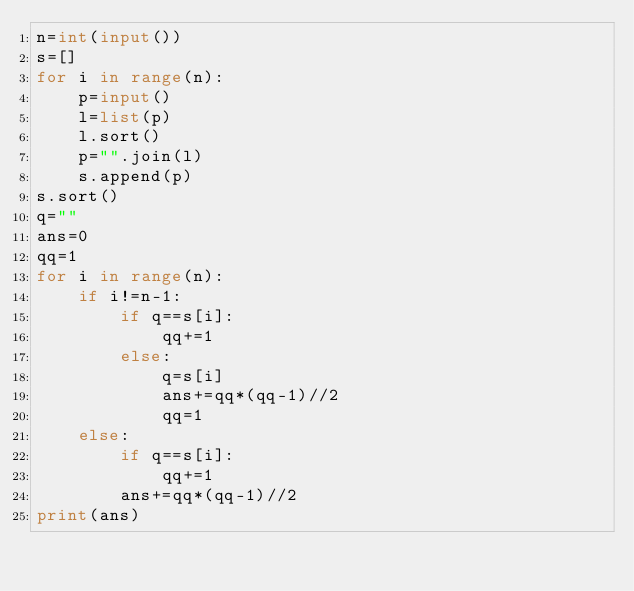<code> <loc_0><loc_0><loc_500><loc_500><_Python_>n=int(input())
s=[]
for i in range(n):
    p=input()
    l=list(p)
    l.sort()
    p="".join(l)
    s.append(p)
s.sort()
q=""
ans=0
qq=1
for i in range(n):
    if i!=n-1:
        if q==s[i]:
            qq+=1
        else:
            q=s[i]
            ans+=qq*(qq-1)//2
            qq=1
    else:
        if q==s[i]:
            qq+=1
        ans+=qq*(qq-1)//2
print(ans)</code> 